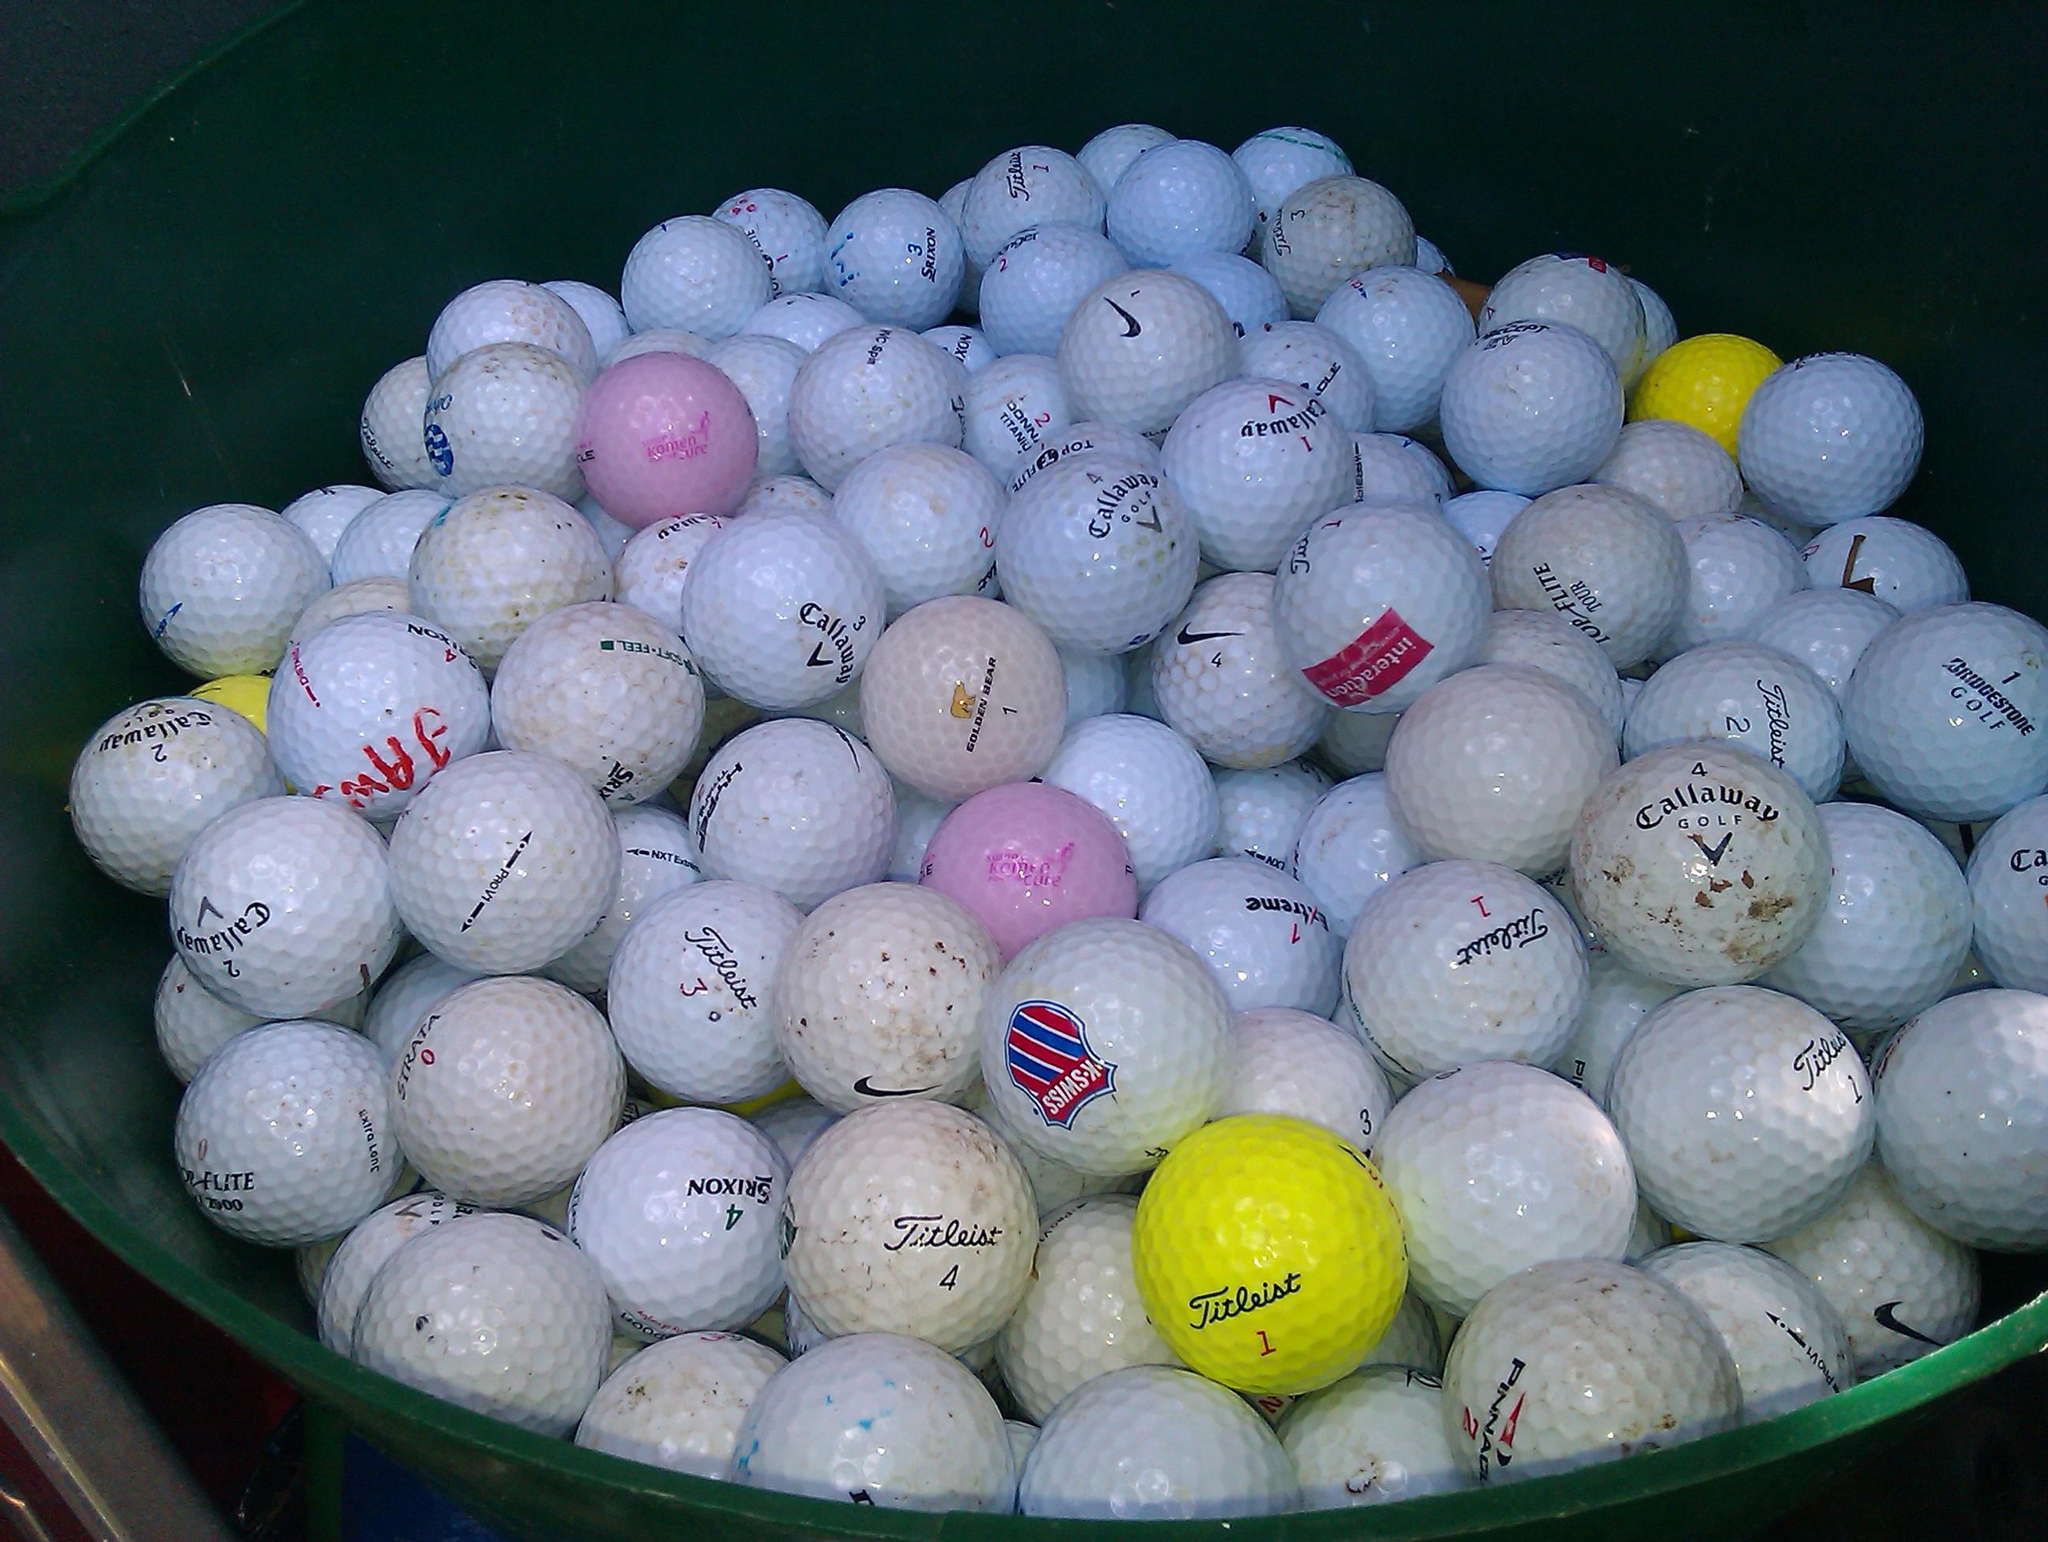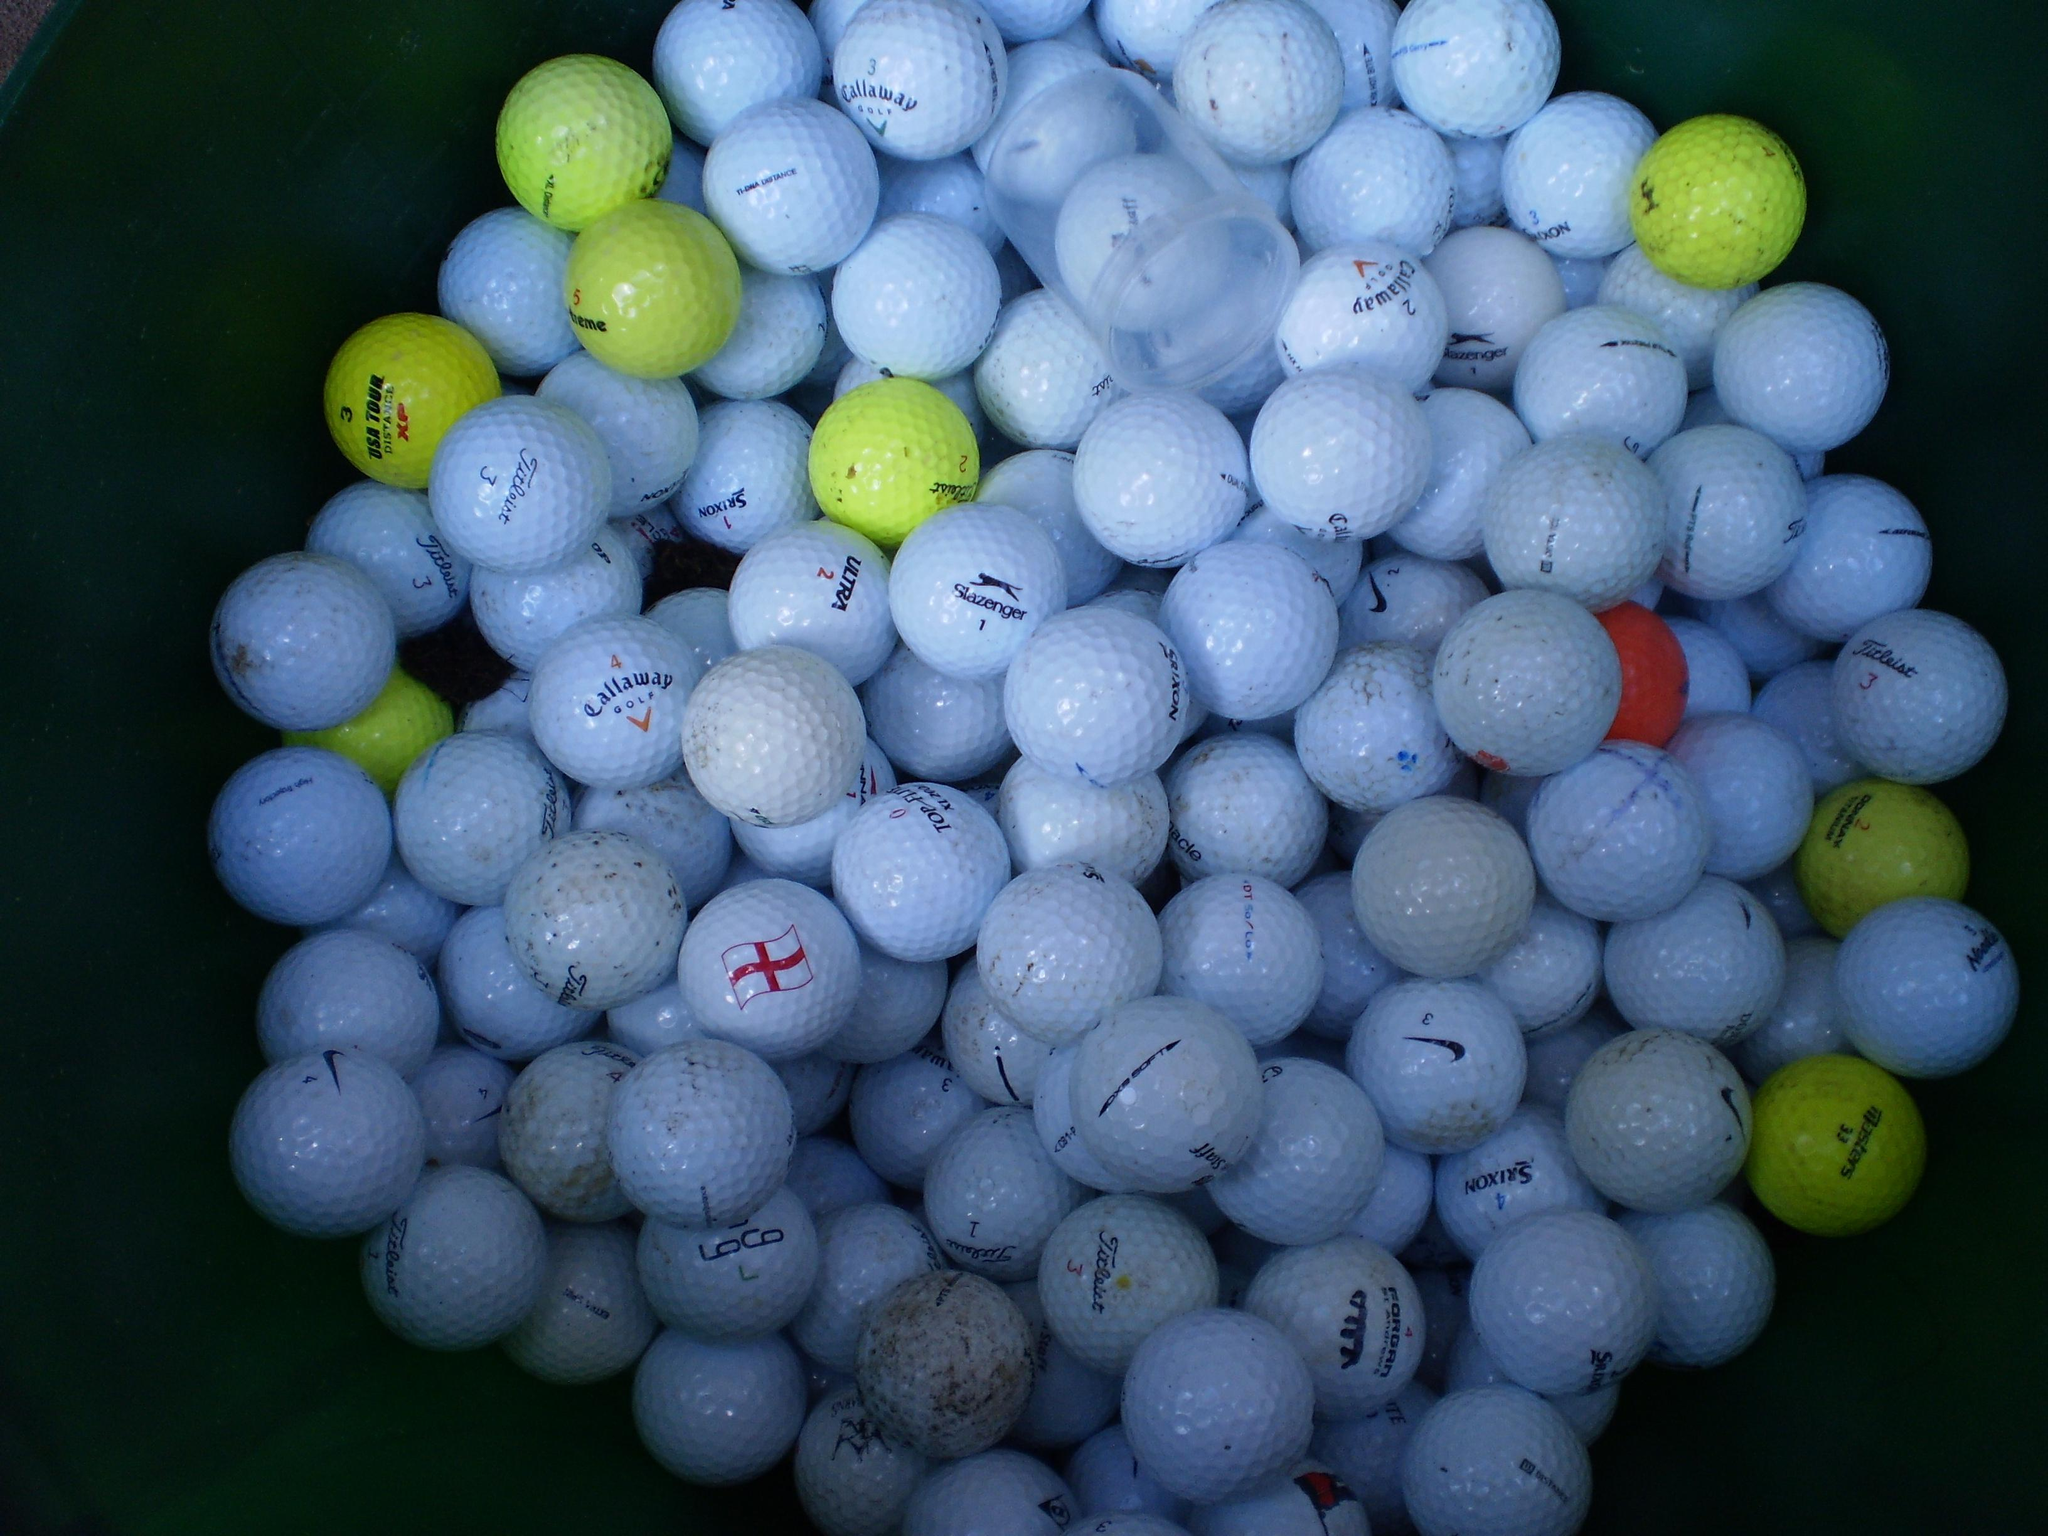The first image is the image on the left, the second image is the image on the right. For the images shown, is this caption "A pile of used golf balls includes at least one pink and one yellow ball." true? Answer yes or no. Yes. The first image is the image on the left, the second image is the image on the right. For the images shown, is this caption "Some of the balls are in a clear container in one of the images." true? Answer yes or no. No. 